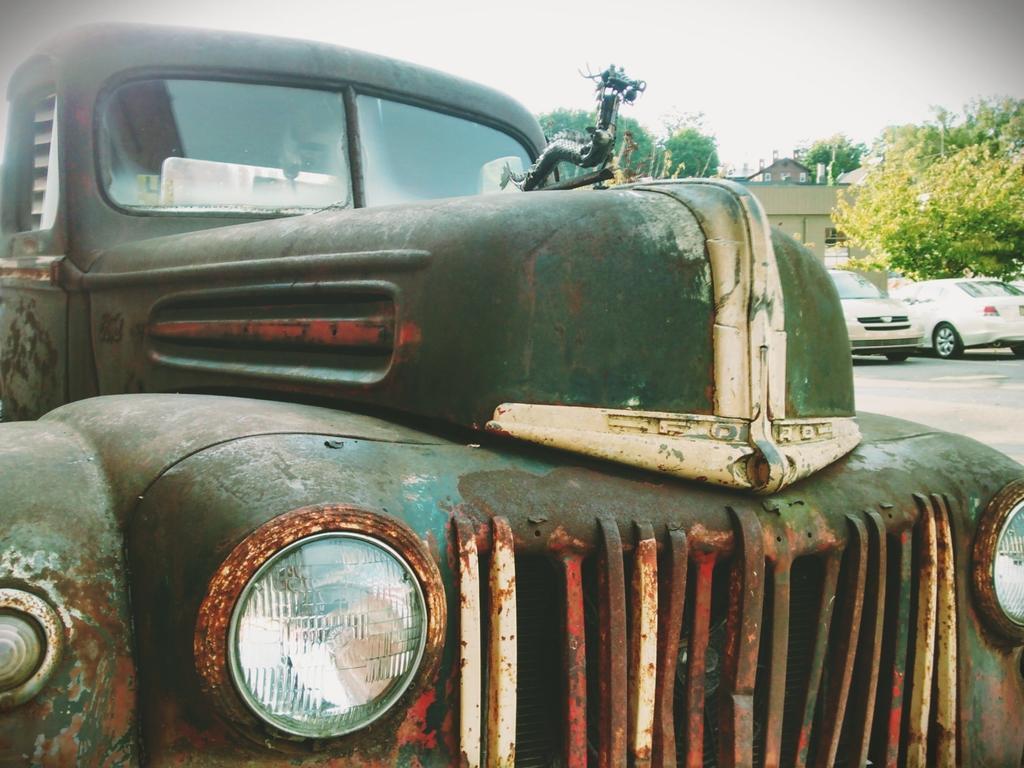Could you give a brief overview of what you see in this image? In this picture we can see a vehicle. In the background of the image we can see cars, trees, buildings and sky. 